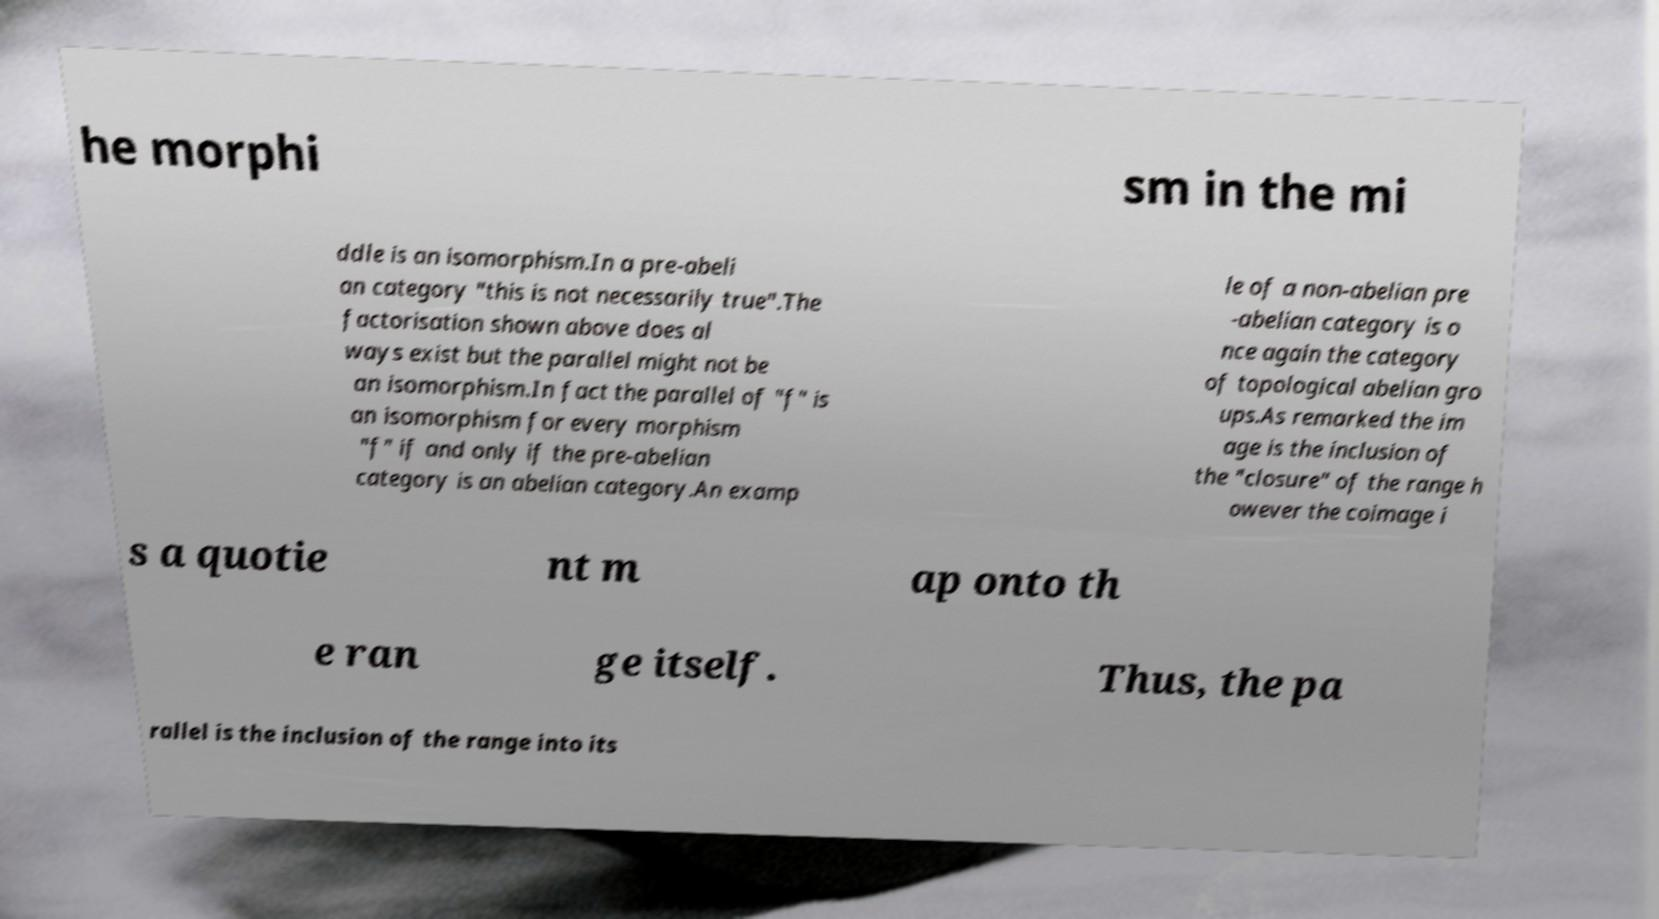What messages or text are displayed in this image? I need them in a readable, typed format. he morphi sm in the mi ddle is an isomorphism.In a pre-abeli an category "this is not necessarily true".The factorisation shown above does al ways exist but the parallel might not be an isomorphism.In fact the parallel of "f" is an isomorphism for every morphism "f" if and only if the pre-abelian category is an abelian category.An examp le of a non-abelian pre -abelian category is o nce again the category of topological abelian gro ups.As remarked the im age is the inclusion of the "closure" of the range h owever the coimage i s a quotie nt m ap onto th e ran ge itself. Thus, the pa rallel is the inclusion of the range into its 